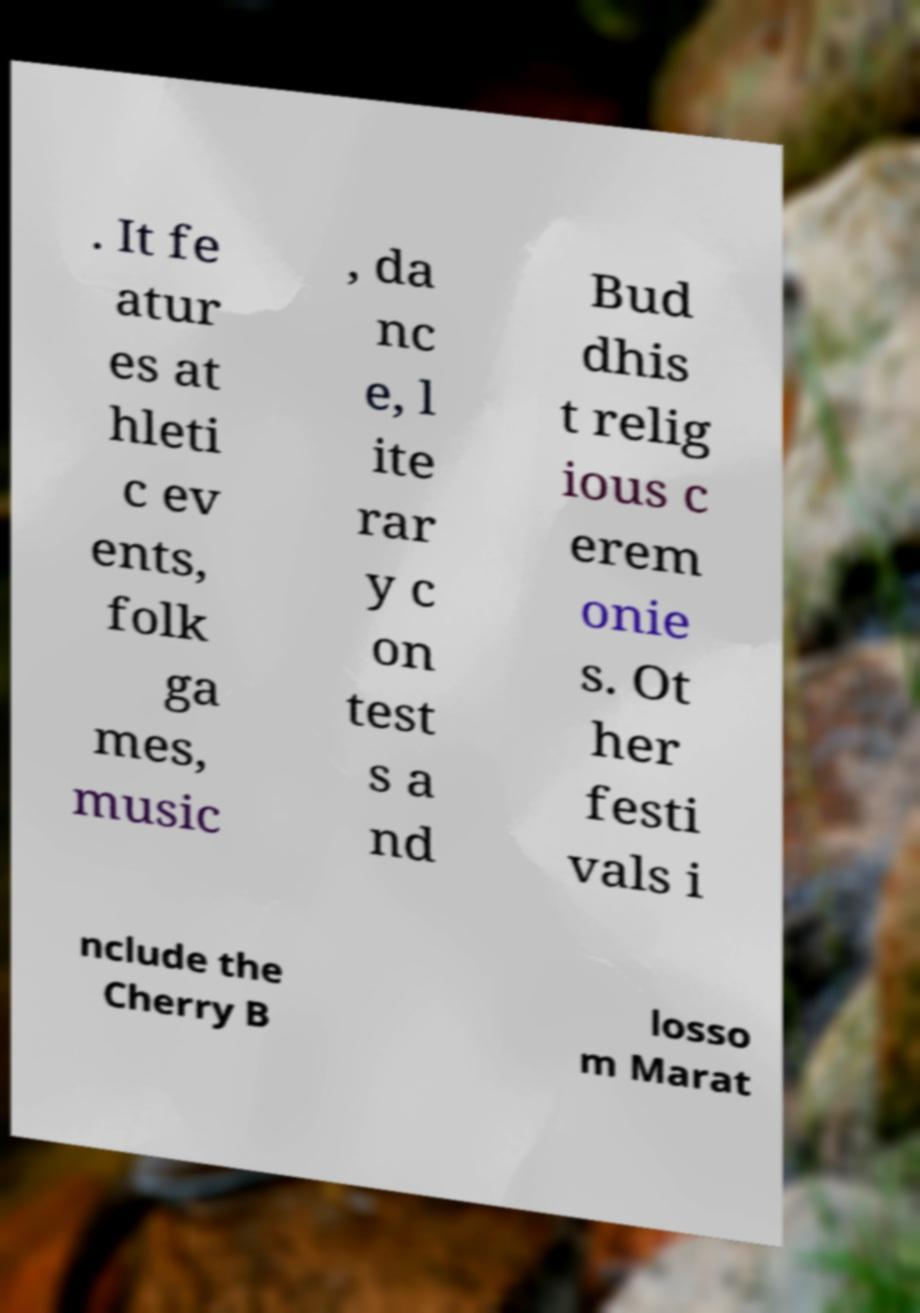Can you read and provide the text displayed in the image?This photo seems to have some interesting text. Can you extract and type it out for me? . It fe atur es at hleti c ev ents, folk ga mes, music , da nc e, l ite rar y c on test s a nd Bud dhis t relig ious c erem onie s. Ot her festi vals i nclude the Cherry B losso m Marat 